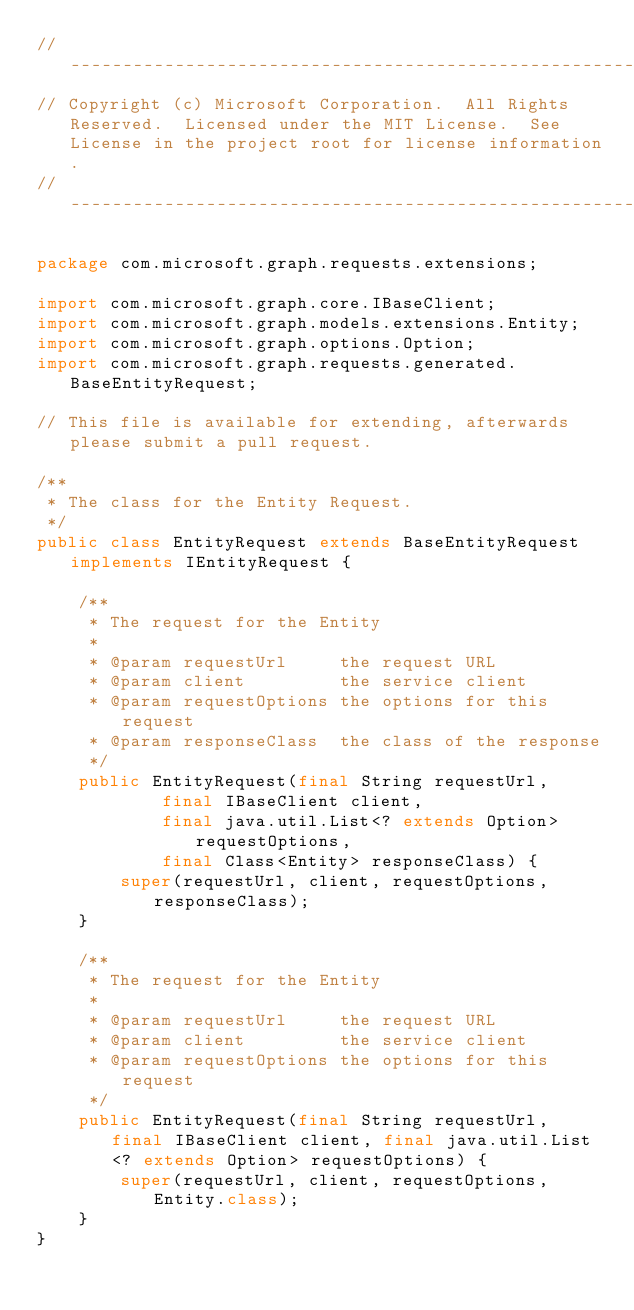<code> <loc_0><loc_0><loc_500><loc_500><_Java_>// ------------------------------------------------------------------------------
// Copyright (c) Microsoft Corporation.  All Rights Reserved.  Licensed under the MIT License.  See License in the project root for license information.
// ------------------------------------------------------------------------------

package com.microsoft.graph.requests.extensions;

import com.microsoft.graph.core.IBaseClient;
import com.microsoft.graph.models.extensions.Entity;
import com.microsoft.graph.options.Option;
import com.microsoft.graph.requests.generated.BaseEntityRequest;

// This file is available for extending, afterwards please submit a pull request.

/**
 * The class for the Entity Request.
 */
public class EntityRequest extends BaseEntityRequest implements IEntityRequest {

    /**
     * The request for the Entity
     *
     * @param requestUrl     the request URL
     * @param client         the service client
     * @param requestOptions the options for this request
     * @param responseClass  the class of the response
     */
    public EntityRequest(final String requestUrl,
            final IBaseClient client,
            final java.util.List<? extends Option> requestOptions,
            final Class<Entity> responseClass) {
        super(requestUrl, client, requestOptions, responseClass);
    }

    /**
     * The request for the Entity
     *
     * @param requestUrl     the request URL
     * @param client         the service client
     * @param requestOptions the options for this request
     */
    public EntityRequest(final String requestUrl, final IBaseClient client, final java.util.List<? extends Option> requestOptions) {
        super(requestUrl, client, requestOptions, Entity.class);
    }
}
</code> 